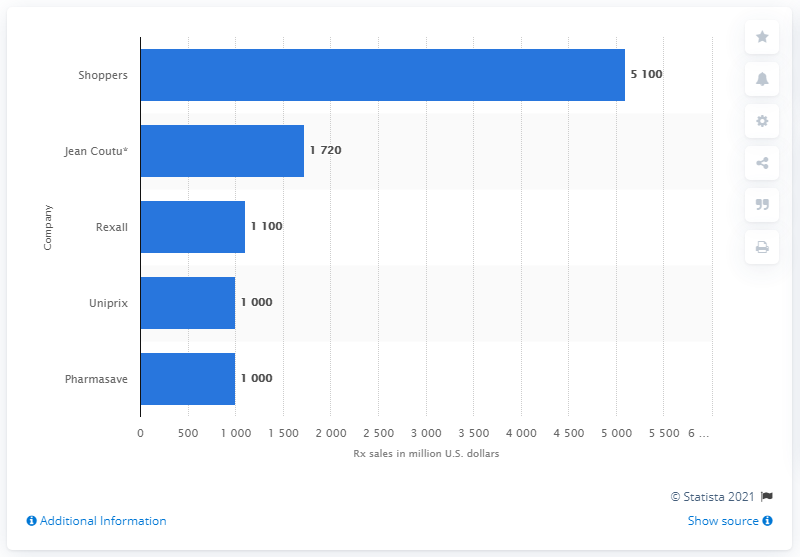Point out several critical features in this image. In 2012, Shoppers Drug Mart was the leading drug store chain in Canada. In 2012, the retail prescription sales of Shoppers in the United States were approximately $5100. 